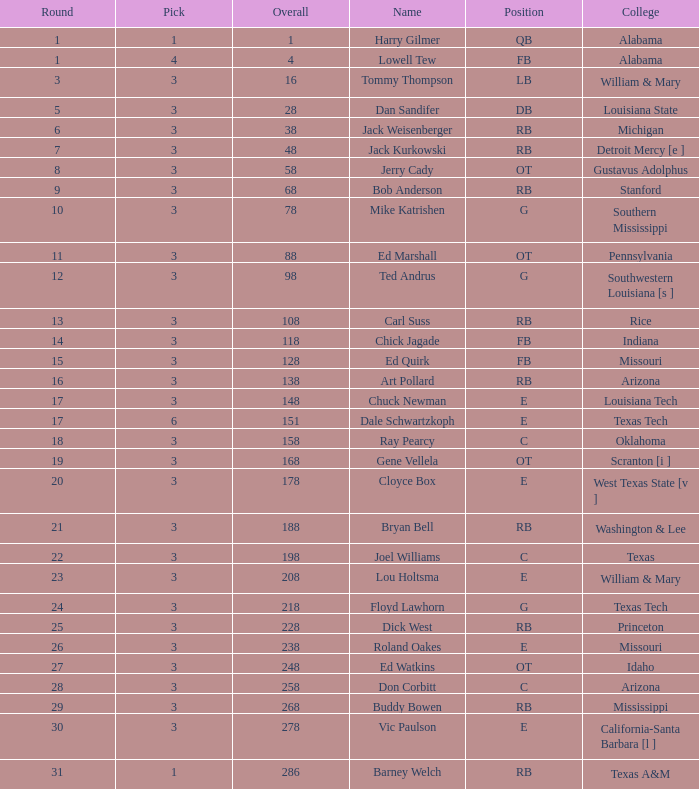Which Overall has a Name of bob anderson, and a Round smaller than 9? None. 